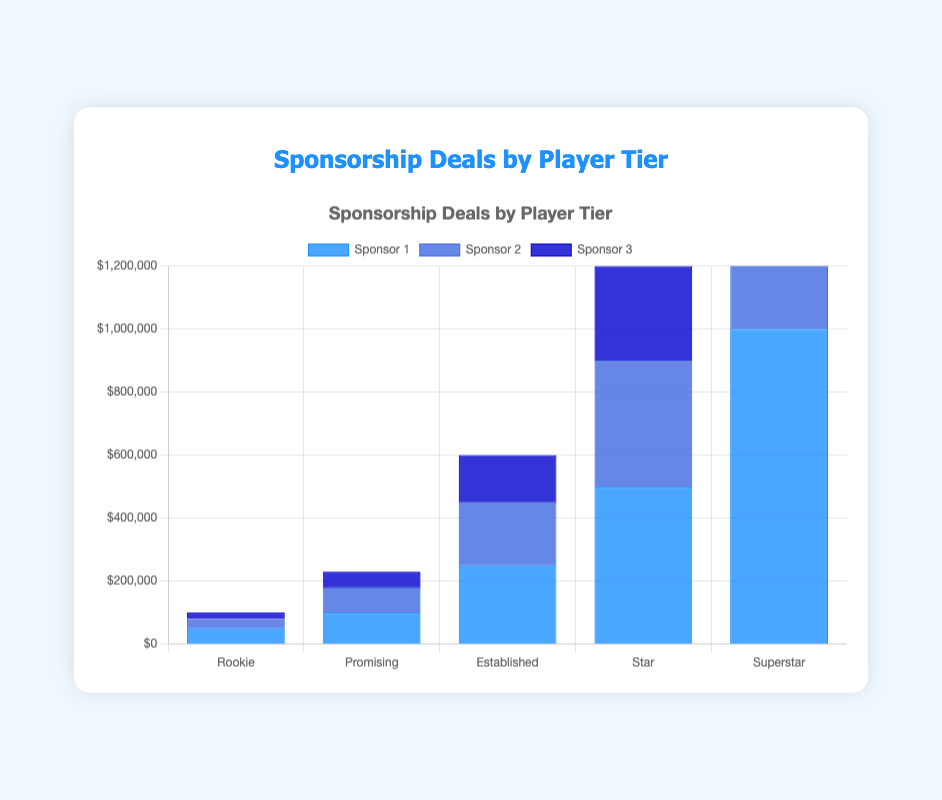Which player tier has the highest total sponsorship deals? To find the highest total sponsorship deals, sum the values of Sponsor 1, Sponsor 2, and Sponsor 3 for each player tier. The total amounts are: Rookie - 100,000, Promising - 230,000, Established - 600,000, Star - 1,200,000, Superstar - 2,400,000. The Superstar tier has the highest total sponsorship deals.
Answer: Superstar How much more does the Star tier receive from Sponsor 1 compared to the Promising tier? Compare the Sponsor 1 amounts for both tiers: Star tier gets 500,000 and Promising tier gets 100,000. The difference is 500,000 - 100,000 = 400,000.
Answer: 400,000 Which sponsor contributes the most to the Rookie tier? The values for the Rookie tier from each sponsor are Sponsor 1: 50,000, Sponsor 2: 30,000, Sponsor 3: 20,000. Sponsor 1 has the highest contribution.
Answer: Sponsor 1 What is the average amount received from Sponsor 2 across all player tiers? Add the amounts from Sponsor 2 for all player tiers: 30,000 + 80,000 + 200,000 + 400,000 + 800,000 = 1,510,000. Divide by the number of player tiers (5): 1,510,000 / 5 = 302,000.
Answer: 302,000 Which player tier has the least amount of sponsorship from Sponsor 3? The values for Sponsor 3 are Rookie - 20,000, Promising - 50,000, Established - 150,000, Star - 300,000, Superstar - 600,000. The Rookie tier has the least amount of sponsorship from Sponsor 3.
Answer: Rookie Is the amount received from Sponsor 1 in the Established tier greater than the combined total of Sponsor 3's contributions to both the Rookie and Promising tiers? Sponsor 1 in Established tier is 250,000. Sponsor 3's contributions to Rookie and Promising tiers are 20,000 + 50,000 = 70,000. 250,000 > 70,000.
Answer: Yes What is the total sponsorship amount for the Promising tier? Sum the amounts from Sponsor 1, Sponsor 2, and Sponsor 3 for the Promising tier: 100,000 + 80,000 + 50,000 = 230,000.
Answer: 230,000 Which color represents the sponsorship amount from Sponsor 2? The colors used for the sponsors are: Sponsor 1 - blue (rgba(30, 144, 255, 0.8)), Sponsor 2 - a deeper shade of blue (rgba(65, 105, 225, 0.8)), Sponsor 3 - dark blue (rgba(0, 0, 205, 0.8)). Hence, Sponsor 2 is represented by a deeper shade of blue.
Answer: deeper blue 